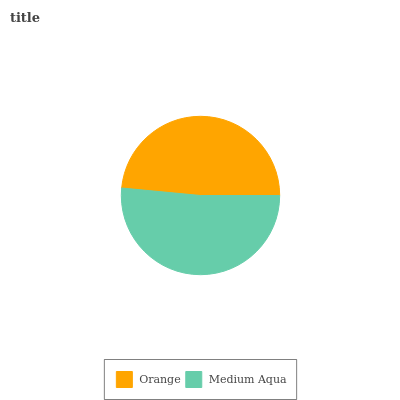Is Orange the minimum?
Answer yes or no. Yes. Is Medium Aqua the maximum?
Answer yes or no. Yes. Is Medium Aqua the minimum?
Answer yes or no. No. Is Medium Aqua greater than Orange?
Answer yes or no. Yes. Is Orange less than Medium Aqua?
Answer yes or no. Yes. Is Orange greater than Medium Aqua?
Answer yes or no. No. Is Medium Aqua less than Orange?
Answer yes or no. No. Is Medium Aqua the high median?
Answer yes or no. Yes. Is Orange the low median?
Answer yes or no. Yes. Is Orange the high median?
Answer yes or no. No. Is Medium Aqua the low median?
Answer yes or no. No. 